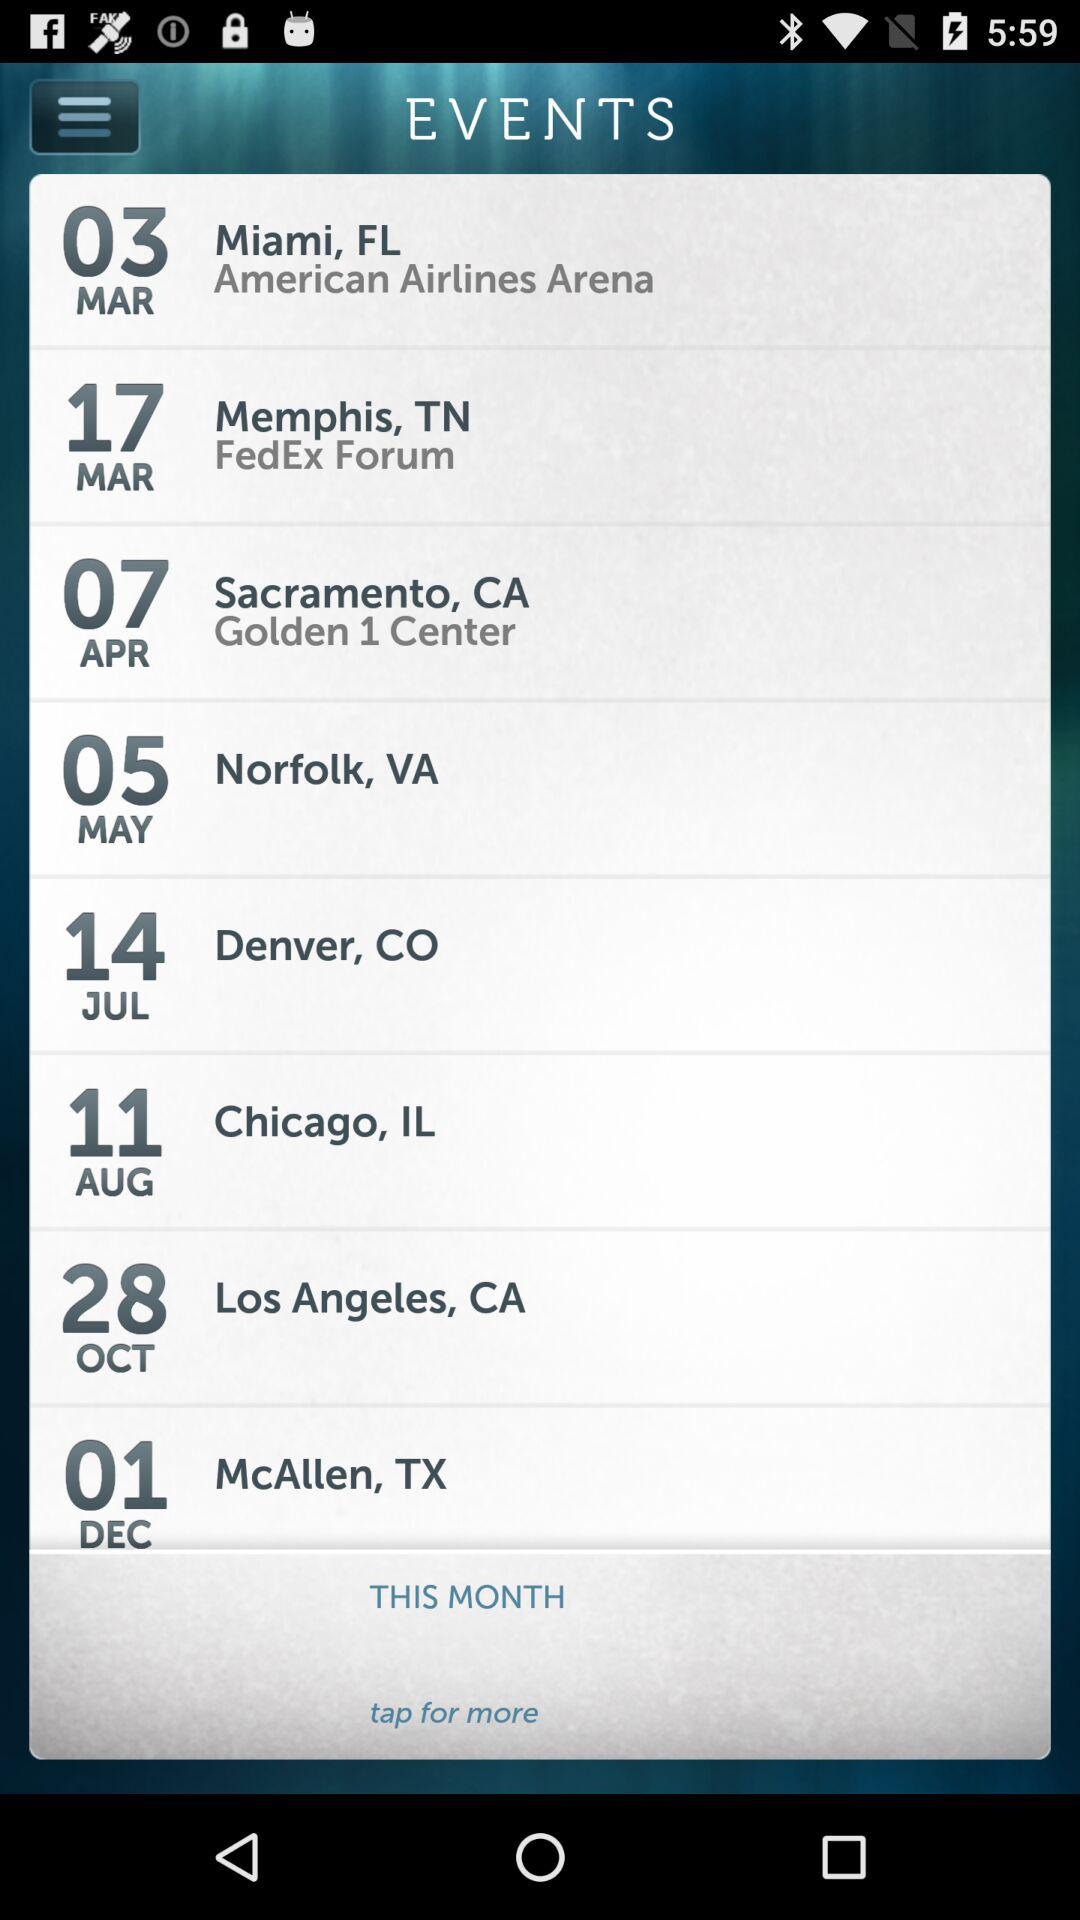What date is mentioned for the event in Chicago? The mentioned date for the event in Chicago is August 11. 